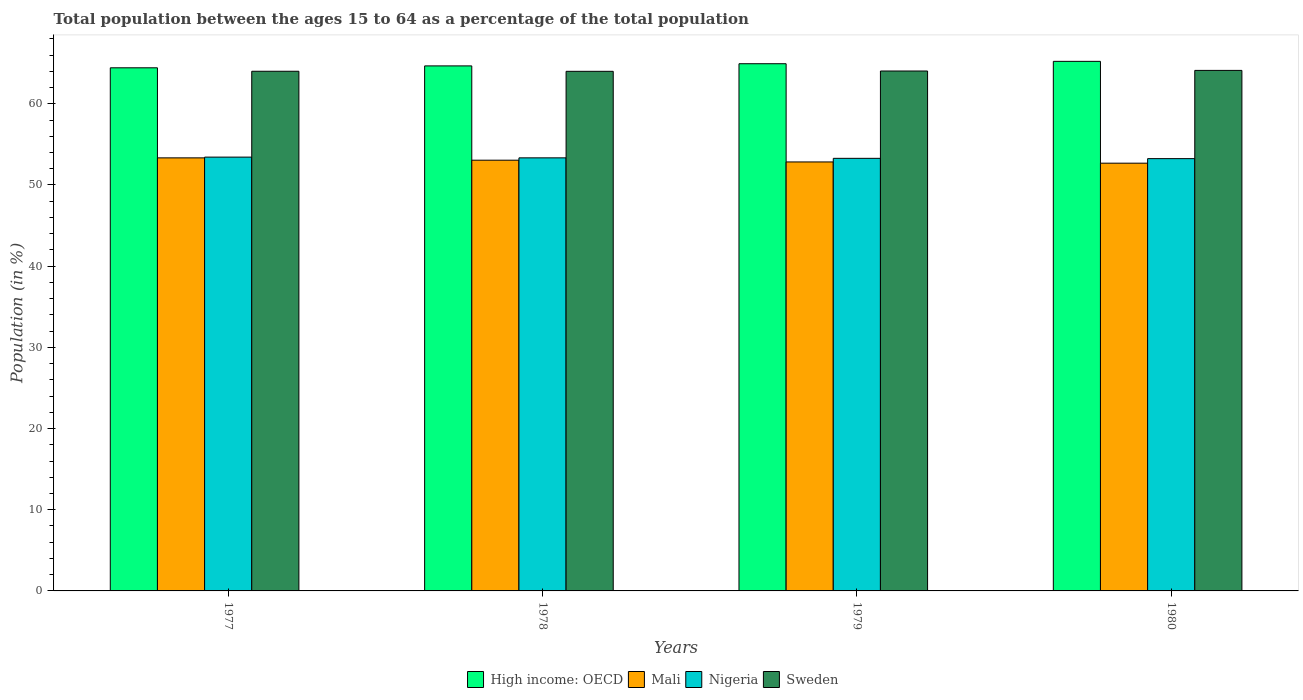Are the number of bars per tick equal to the number of legend labels?
Ensure brevity in your answer.  Yes. Are the number of bars on each tick of the X-axis equal?
Make the answer very short. Yes. How many bars are there on the 1st tick from the right?
Your answer should be very brief. 4. What is the label of the 2nd group of bars from the left?
Provide a succinct answer. 1978. What is the percentage of the population ages 15 to 64 in Mali in 1977?
Provide a short and direct response. 53.34. Across all years, what is the maximum percentage of the population ages 15 to 64 in High income: OECD?
Your answer should be compact. 65.23. Across all years, what is the minimum percentage of the population ages 15 to 64 in Sweden?
Ensure brevity in your answer.  64. In which year was the percentage of the population ages 15 to 64 in Mali maximum?
Provide a succinct answer. 1977. In which year was the percentage of the population ages 15 to 64 in Nigeria minimum?
Your answer should be compact. 1980. What is the total percentage of the population ages 15 to 64 in Nigeria in the graph?
Your answer should be very brief. 213.31. What is the difference between the percentage of the population ages 15 to 64 in Sweden in 1979 and that in 1980?
Keep it short and to the point. -0.07. What is the difference between the percentage of the population ages 15 to 64 in Nigeria in 1978 and the percentage of the population ages 15 to 64 in Mali in 1979?
Provide a short and direct response. 0.5. What is the average percentage of the population ages 15 to 64 in Nigeria per year?
Make the answer very short. 53.33. In the year 1980, what is the difference between the percentage of the population ages 15 to 64 in Nigeria and percentage of the population ages 15 to 64 in High income: OECD?
Keep it short and to the point. -11.98. In how many years, is the percentage of the population ages 15 to 64 in High income: OECD greater than 16?
Provide a succinct answer. 4. What is the ratio of the percentage of the population ages 15 to 64 in Nigeria in 1979 to that in 1980?
Make the answer very short. 1. Is the percentage of the population ages 15 to 64 in Sweden in 1977 less than that in 1978?
Your answer should be compact. No. Is the difference between the percentage of the population ages 15 to 64 in Nigeria in 1977 and 1980 greater than the difference between the percentage of the population ages 15 to 64 in High income: OECD in 1977 and 1980?
Offer a terse response. Yes. What is the difference between the highest and the second highest percentage of the population ages 15 to 64 in Nigeria?
Give a very brief answer. 0.09. What is the difference between the highest and the lowest percentage of the population ages 15 to 64 in Nigeria?
Your response must be concise. 0.19. Is the sum of the percentage of the population ages 15 to 64 in Mali in 1977 and 1980 greater than the maximum percentage of the population ages 15 to 64 in Sweden across all years?
Give a very brief answer. Yes. What does the 1st bar from the left in 1980 represents?
Provide a short and direct response. High income: OECD. What does the 4th bar from the right in 1977 represents?
Your answer should be very brief. High income: OECD. How many bars are there?
Your response must be concise. 16. Are all the bars in the graph horizontal?
Your response must be concise. No. How many years are there in the graph?
Your answer should be compact. 4. Does the graph contain any zero values?
Your answer should be compact. No. How many legend labels are there?
Your response must be concise. 4. How are the legend labels stacked?
Provide a succinct answer. Horizontal. What is the title of the graph?
Provide a succinct answer. Total population between the ages 15 to 64 as a percentage of the total population. Does "Haiti" appear as one of the legend labels in the graph?
Your response must be concise. No. What is the label or title of the X-axis?
Provide a short and direct response. Years. What is the Population (in %) of High income: OECD in 1977?
Your answer should be compact. 64.44. What is the Population (in %) in Mali in 1977?
Provide a short and direct response. 53.34. What is the Population (in %) in Nigeria in 1977?
Provide a short and direct response. 53.43. What is the Population (in %) of Sweden in 1977?
Offer a very short reply. 64.01. What is the Population (in %) of High income: OECD in 1978?
Give a very brief answer. 64.67. What is the Population (in %) of Mali in 1978?
Your answer should be very brief. 53.05. What is the Population (in %) in Nigeria in 1978?
Ensure brevity in your answer.  53.34. What is the Population (in %) of Sweden in 1978?
Provide a succinct answer. 64. What is the Population (in %) in High income: OECD in 1979?
Provide a short and direct response. 64.94. What is the Population (in %) of Mali in 1979?
Make the answer very short. 52.84. What is the Population (in %) of Nigeria in 1979?
Ensure brevity in your answer.  53.28. What is the Population (in %) of Sweden in 1979?
Your response must be concise. 64.04. What is the Population (in %) of High income: OECD in 1980?
Offer a terse response. 65.23. What is the Population (in %) in Mali in 1980?
Your response must be concise. 52.69. What is the Population (in %) in Nigeria in 1980?
Offer a terse response. 53.25. What is the Population (in %) of Sweden in 1980?
Make the answer very short. 64.12. Across all years, what is the maximum Population (in %) in High income: OECD?
Your response must be concise. 65.23. Across all years, what is the maximum Population (in %) of Mali?
Ensure brevity in your answer.  53.34. Across all years, what is the maximum Population (in %) of Nigeria?
Provide a succinct answer. 53.43. Across all years, what is the maximum Population (in %) of Sweden?
Your answer should be very brief. 64.12. Across all years, what is the minimum Population (in %) of High income: OECD?
Offer a very short reply. 64.44. Across all years, what is the minimum Population (in %) in Mali?
Offer a terse response. 52.69. Across all years, what is the minimum Population (in %) in Nigeria?
Keep it short and to the point. 53.25. Across all years, what is the minimum Population (in %) of Sweden?
Give a very brief answer. 64. What is the total Population (in %) in High income: OECD in the graph?
Keep it short and to the point. 259.27. What is the total Population (in %) of Mali in the graph?
Your answer should be very brief. 211.92. What is the total Population (in %) of Nigeria in the graph?
Offer a terse response. 213.31. What is the total Population (in %) in Sweden in the graph?
Provide a short and direct response. 256.17. What is the difference between the Population (in %) in High income: OECD in 1977 and that in 1978?
Keep it short and to the point. -0.23. What is the difference between the Population (in %) of Mali in 1977 and that in 1978?
Make the answer very short. 0.29. What is the difference between the Population (in %) of Nigeria in 1977 and that in 1978?
Provide a short and direct response. 0.09. What is the difference between the Population (in %) in Sweden in 1977 and that in 1978?
Ensure brevity in your answer.  0.01. What is the difference between the Population (in %) of High income: OECD in 1977 and that in 1979?
Your answer should be very brief. -0.5. What is the difference between the Population (in %) in Mali in 1977 and that in 1979?
Keep it short and to the point. 0.5. What is the difference between the Population (in %) in Nigeria in 1977 and that in 1979?
Make the answer very short. 0.15. What is the difference between the Population (in %) of Sweden in 1977 and that in 1979?
Offer a very short reply. -0.03. What is the difference between the Population (in %) in High income: OECD in 1977 and that in 1980?
Keep it short and to the point. -0.79. What is the difference between the Population (in %) of Mali in 1977 and that in 1980?
Provide a succinct answer. 0.65. What is the difference between the Population (in %) in Nigeria in 1977 and that in 1980?
Keep it short and to the point. 0.19. What is the difference between the Population (in %) of Sweden in 1977 and that in 1980?
Give a very brief answer. -0.11. What is the difference between the Population (in %) in High income: OECD in 1978 and that in 1979?
Your answer should be very brief. -0.27. What is the difference between the Population (in %) of Mali in 1978 and that in 1979?
Ensure brevity in your answer.  0.21. What is the difference between the Population (in %) in Nigeria in 1978 and that in 1979?
Offer a terse response. 0.06. What is the difference between the Population (in %) of Sweden in 1978 and that in 1979?
Provide a short and direct response. -0.04. What is the difference between the Population (in %) of High income: OECD in 1978 and that in 1980?
Make the answer very short. -0.56. What is the difference between the Population (in %) of Mali in 1978 and that in 1980?
Give a very brief answer. 0.37. What is the difference between the Population (in %) of Nigeria in 1978 and that in 1980?
Offer a terse response. 0.1. What is the difference between the Population (in %) of Sweden in 1978 and that in 1980?
Provide a short and direct response. -0.11. What is the difference between the Population (in %) of High income: OECD in 1979 and that in 1980?
Give a very brief answer. -0.29. What is the difference between the Population (in %) of Mali in 1979 and that in 1980?
Your answer should be compact. 0.15. What is the difference between the Population (in %) in Nigeria in 1979 and that in 1980?
Offer a terse response. 0.04. What is the difference between the Population (in %) of Sweden in 1979 and that in 1980?
Provide a short and direct response. -0.07. What is the difference between the Population (in %) in High income: OECD in 1977 and the Population (in %) in Mali in 1978?
Make the answer very short. 11.38. What is the difference between the Population (in %) in High income: OECD in 1977 and the Population (in %) in Nigeria in 1978?
Provide a short and direct response. 11.09. What is the difference between the Population (in %) in High income: OECD in 1977 and the Population (in %) in Sweden in 1978?
Your answer should be compact. 0.43. What is the difference between the Population (in %) of Mali in 1977 and the Population (in %) of Nigeria in 1978?
Offer a terse response. -0. What is the difference between the Population (in %) in Mali in 1977 and the Population (in %) in Sweden in 1978?
Provide a succinct answer. -10.66. What is the difference between the Population (in %) of Nigeria in 1977 and the Population (in %) of Sweden in 1978?
Your answer should be very brief. -10.57. What is the difference between the Population (in %) of High income: OECD in 1977 and the Population (in %) of Mali in 1979?
Provide a short and direct response. 11.6. What is the difference between the Population (in %) in High income: OECD in 1977 and the Population (in %) in Nigeria in 1979?
Provide a succinct answer. 11.15. What is the difference between the Population (in %) of High income: OECD in 1977 and the Population (in %) of Sweden in 1979?
Ensure brevity in your answer.  0.4. What is the difference between the Population (in %) in Mali in 1977 and the Population (in %) in Nigeria in 1979?
Offer a terse response. 0.06. What is the difference between the Population (in %) of Mali in 1977 and the Population (in %) of Sweden in 1979?
Offer a very short reply. -10.7. What is the difference between the Population (in %) of Nigeria in 1977 and the Population (in %) of Sweden in 1979?
Make the answer very short. -10.61. What is the difference between the Population (in %) of High income: OECD in 1977 and the Population (in %) of Mali in 1980?
Make the answer very short. 11.75. What is the difference between the Population (in %) in High income: OECD in 1977 and the Population (in %) in Nigeria in 1980?
Your answer should be compact. 11.19. What is the difference between the Population (in %) of High income: OECD in 1977 and the Population (in %) of Sweden in 1980?
Keep it short and to the point. 0.32. What is the difference between the Population (in %) of Mali in 1977 and the Population (in %) of Nigeria in 1980?
Offer a terse response. 0.09. What is the difference between the Population (in %) in Mali in 1977 and the Population (in %) in Sweden in 1980?
Your response must be concise. -10.77. What is the difference between the Population (in %) of Nigeria in 1977 and the Population (in %) of Sweden in 1980?
Ensure brevity in your answer.  -10.68. What is the difference between the Population (in %) in High income: OECD in 1978 and the Population (in %) in Mali in 1979?
Offer a very short reply. 11.83. What is the difference between the Population (in %) in High income: OECD in 1978 and the Population (in %) in Nigeria in 1979?
Your response must be concise. 11.39. What is the difference between the Population (in %) of High income: OECD in 1978 and the Population (in %) of Sweden in 1979?
Your answer should be compact. 0.63. What is the difference between the Population (in %) in Mali in 1978 and the Population (in %) in Nigeria in 1979?
Offer a terse response. -0.23. What is the difference between the Population (in %) of Mali in 1978 and the Population (in %) of Sweden in 1979?
Ensure brevity in your answer.  -10.99. What is the difference between the Population (in %) in Nigeria in 1978 and the Population (in %) in Sweden in 1979?
Offer a very short reply. -10.7. What is the difference between the Population (in %) of High income: OECD in 1978 and the Population (in %) of Mali in 1980?
Provide a short and direct response. 11.98. What is the difference between the Population (in %) in High income: OECD in 1978 and the Population (in %) in Nigeria in 1980?
Your answer should be very brief. 11.42. What is the difference between the Population (in %) in High income: OECD in 1978 and the Population (in %) in Sweden in 1980?
Give a very brief answer. 0.55. What is the difference between the Population (in %) of Mali in 1978 and the Population (in %) of Nigeria in 1980?
Provide a succinct answer. -0.19. What is the difference between the Population (in %) in Mali in 1978 and the Population (in %) in Sweden in 1980?
Your answer should be very brief. -11.06. What is the difference between the Population (in %) in Nigeria in 1978 and the Population (in %) in Sweden in 1980?
Give a very brief answer. -10.77. What is the difference between the Population (in %) in High income: OECD in 1979 and the Population (in %) in Mali in 1980?
Provide a succinct answer. 12.25. What is the difference between the Population (in %) of High income: OECD in 1979 and the Population (in %) of Nigeria in 1980?
Provide a short and direct response. 11.69. What is the difference between the Population (in %) in High income: OECD in 1979 and the Population (in %) in Sweden in 1980?
Give a very brief answer. 0.82. What is the difference between the Population (in %) of Mali in 1979 and the Population (in %) of Nigeria in 1980?
Offer a terse response. -0.41. What is the difference between the Population (in %) of Mali in 1979 and the Population (in %) of Sweden in 1980?
Offer a very short reply. -11.27. What is the difference between the Population (in %) of Nigeria in 1979 and the Population (in %) of Sweden in 1980?
Your response must be concise. -10.83. What is the average Population (in %) of High income: OECD per year?
Keep it short and to the point. 64.82. What is the average Population (in %) in Mali per year?
Provide a succinct answer. 52.98. What is the average Population (in %) in Nigeria per year?
Your response must be concise. 53.33. What is the average Population (in %) in Sweden per year?
Give a very brief answer. 64.04. In the year 1977, what is the difference between the Population (in %) of High income: OECD and Population (in %) of Mali?
Make the answer very short. 11.09. In the year 1977, what is the difference between the Population (in %) of High income: OECD and Population (in %) of Nigeria?
Ensure brevity in your answer.  11. In the year 1977, what is the difference between the Population (in %) in High income: OECD and Population (in %) in Sweden?
Offer a very short reply. 0.43. In the year 1977, what is the difference between the Population (in %) of Mali and Population (in %) of Nigeria?
Provide a succinct answer. -0.09. In the year 1977, what is the difference between the Population (in %) in Mali and Population (in %) in Sweden?
Offer a very short reply. -10.67. In the year 1977, what is the difference between the Population (in %) in Nigeria and Population (in %) in Sweden?
Provide a succinct answer. -10.58. In the year 1978, what is the difference between the Population (in %) in High income: OECD and Population (in %) in Mali?
Keep it short and to the point. 11.62. In the year 1978, what is the difference between the Population (in %) of High income: OECD and Population (in %) of Nigeria?
Ensure brevity in your answer.  11.33. In the year 1978, what is the difference between the Population (in %) in High income: OECD and Population (in %) in Sweden?
Your answer should be very brief. 0.67. In the year 1978, what is the difference between the Population (in %) of Mali and Population (in %) of Nigeria?
Offer a very short reply. -0.29. In the year 1978, what is the difference between the Population (in %) of Mali and Population (in %) of Sweden?
Make the answer very short. -10.95. In the year 1978, what is the difference between the Population (in %) of Nigeria and Population (in %) of Sweden?
Make the answer very short. -10.66. In the year 1979, what is the difference between the Population (in %) of High income: OECD and Population (in %) of Mali?
Your answer should be compact. 12.1. In the year 1979, what is the difference between the Population (in %) in High income: OECD and Population (in %) in Nigeria?
Ensure brevity in your answer.  11.65. In the year 1979, what is the difference between the Population (in %) of High income: OECD and Population (in %) of Sweden?
Your answer should be very brief. 0.9. In the year 1979, what is the difference between the Population (in %) of Mali and Population (in %) of Nigeria?
Your answer should be compact. -0.44. In the year 1979, what is the difference between the Population (in %) in Mali and Population (in %) in Sweden?
Provide a succinct answer. -11.2. In the year 1979, what is the difference between the Population (in %) of Nigeria and Population (in %) of Sweden?
Your response must be concise. -10.76. In the year 1980, what is the difference between the Population (in %) of High income: OECD and Population (in %) of Mali?
Offer a very short reply. 12.54. In the year 1980, what is the difference between the Population (in %) of High income: OECD and Population (in %) of Nigeria?
Give a very brief answer. 11.98. In the year 1980, what is the difference between the Population (in %) in High income: OECD and Population (in %) in Sweden?
Give a very brief answer. 1.11. In the year 1980, what is the difference between the Population (in %) of Mali and Population (in %) of Nigeria?
Give a very brief answer. -0.56. In the year 1980, what is the difference between the Population (in %) in Mali and Population (in %) in Sweden?
Offer a very short reply. -11.43. In the year 1980, what is the difference between the Population (in %) of Nigeria and Population (in %) of Sweden?
Your response must be concise. -10.87. What is the ratio of the Population (in %) in High income: OECD in 1977 to that in 1978?
Your response must be concise. 1. What is the ratio of the Population (in %) in Mali in 1977 to that in 1978?
Your answer should be compact. 1.01. What is the ratio of the Population (in %) of High income: OECD in 1977 to that in 1979?
Give a very brief answer. 0.99. What is the ratio of the Population (in %) of Mali in 1977 to that in 1979?
Ensure brevity in your answer.  1.01. What is the ratio of the Population (in %) of Nigeria in 1977 to that in 1979?
Make the answer very short. 1. What is the ratio of the Population (in %) in Mali in 1977 to that in 1980?
Offer a terse response. 1.01. What is the ratio of the Population (in %) of Nigeria in 1977 to that in 1980?
Give a very brief answer. 1. What is the ratio of the Population (in %) of Mali in 1978 to that in 1979?
Keep it short and to the point. 1. What is the ratio of the Population (in %) in Mali in 1978 to that in 1980?
Offer a very short reply. 1.01. What is the ratio of the Population (in %) in Nigeria in 1978 to that in 1980?
Ensure brevity in your answer.  1. What is the ratio of the Population (in %) in Mali in 1979 to that in 1980?
Keep it short and to the point. 1. What is the ratio of the Population (in %) of Nigeria in 1979 to that in 1980?
Give a very brief answer. 1. What is the difference between the highest and the second highest Population (in %) of High income: OECD?
Offer a very short reply. 0.29. What is the difference between the highest and the second highest Population (in %) in Mali?
Your answer should be very brief. 0.29. What is the difference between the highest and the second highest Population (in %) in Nigeria?
Offer a very short reply. 0.09. What is the difference between the highest and the second highest Population (in %) of Sweden?
Your answer should be compact. 0.07. What is the difference between the highest and the lowest Population (in %) of High income: OECD?
Give a very brief answer. 0.79. What is the difference between the highest and the lowest Population (in %) in Mali?
Offer a very short reply. 0.65. What is the difference between the highest and the lowest Population (in %) of Nigeria?
Ensure brevity in your answer.  0.19. What is the difference between the highest and the lowest Population (in %) in Sweden?
Your answer should be compact. 0.11. 